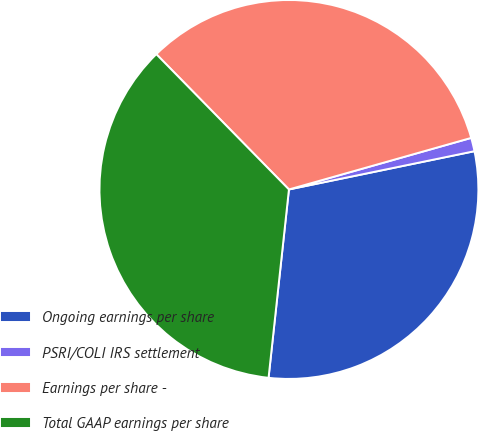Convert chart. <chart><loc_0><loc_0><loc_500><loc_500><pie_chart><fcel>Ongoing earnings per share<fcel>PSRI/COLI IRS settlement<fcel>Earnings per share -<fcel>Total GAAP earnings per share<nl><fcel>29.95%<fcel>1.15%<fcel>32.95%<fcel>35.94%<nl></chart> 